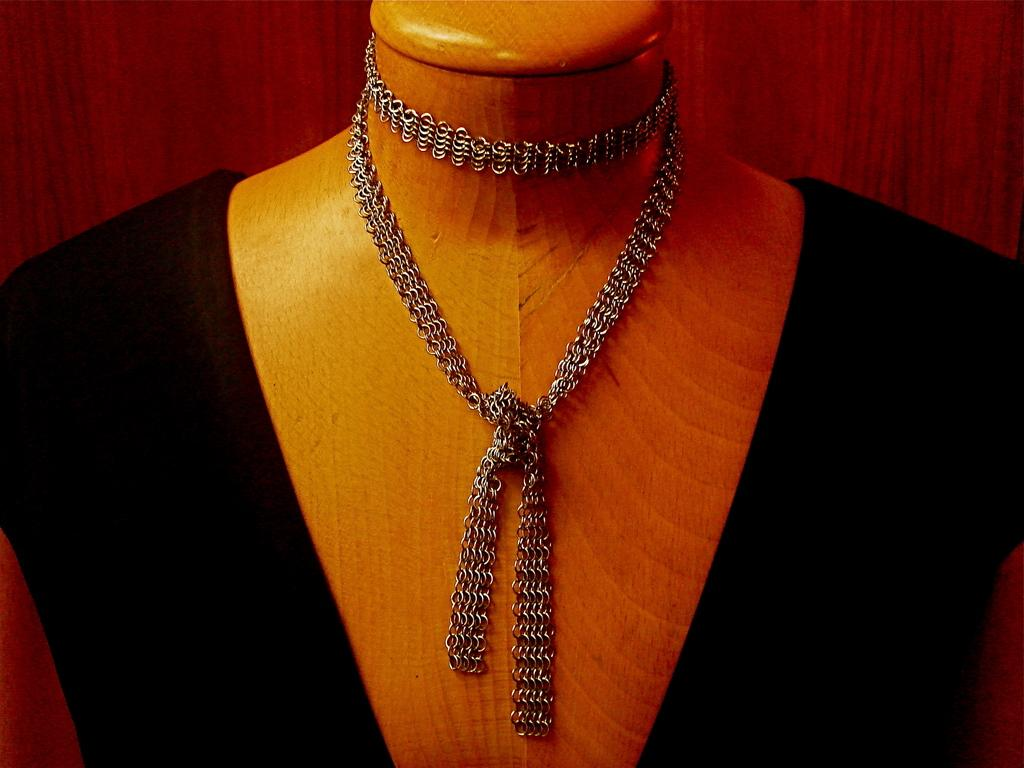What is the main subject of the image? The main subject of the image is a person's body without a face. What color is the dress the person is wearing? The person is wearing a black color dress. What accessory is visible on the person's neck? There is a chain visible on the person's neck. What type of glove is the person wearing in the image? There is no glove visible in the image; the person is wearing a black color dress and has a chain visible on their neck. 